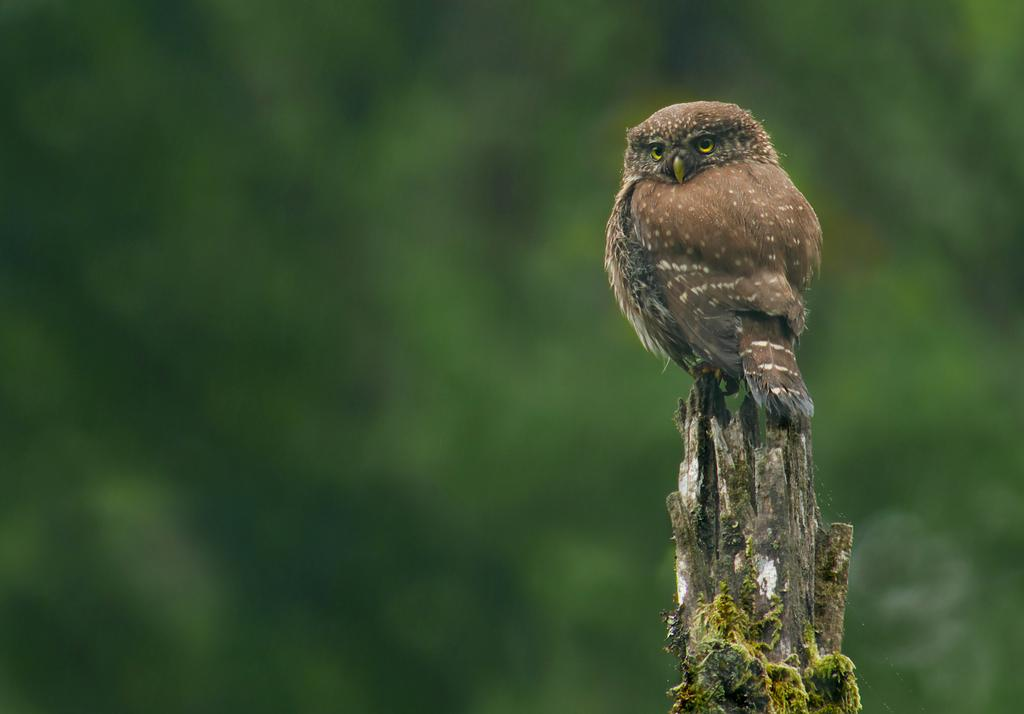What animal is in the picture? There is an owl in the picture. Where is the owl located? The owl is sitting on the stem of a tree. Can you describe the background of the image? The background of the image is blurred. What type of comfort can be seen in the image? There is no reference to comfort in the image, as it features an owl sitting on a tree. Is there a cannon visible in the image? No, there is no cannon present in the image. 